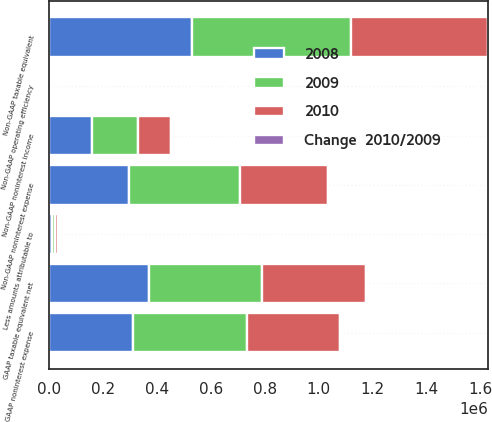Convert chart to OTSL. <chart><loc_0><loc_0><loc_500><loc_500><stacked_bar_chart><ecel><fcel>GAAP noninterest expense<fcel>Less amounts attributable to<fcel>Non-GAAP noninterest expense<fcel>GAAP taxable equivalent net<fcel>Non-GAAP taxable equivalent<fcel>Non-GAAP noninterest income<fcel>Non-GAAP operating efficiency<nl><fcel>2009<fcel>422818<fcel>12348<fcel>410470<fcel>420186<fcel>588803<fcel>168645<fcel>69.71<nl><fcel>2010<fcel>343866<fcel>12451<fcel>327323<fcel>384354<fcel>507016<fcel>122644<fcel>64.56<nl><fcel>Change  2010/2009<fcel>23<fcel>0.8<fcel>25.4<fcel>9.3<fcel>16.1<fcel>37.5<fcel>8<nl><fcel>2008<fcel>312887<fcel>11115<fcel>297914<fcel>370889<fcel>531278<fcel>160859<fcel>56.07<nl></chart> 